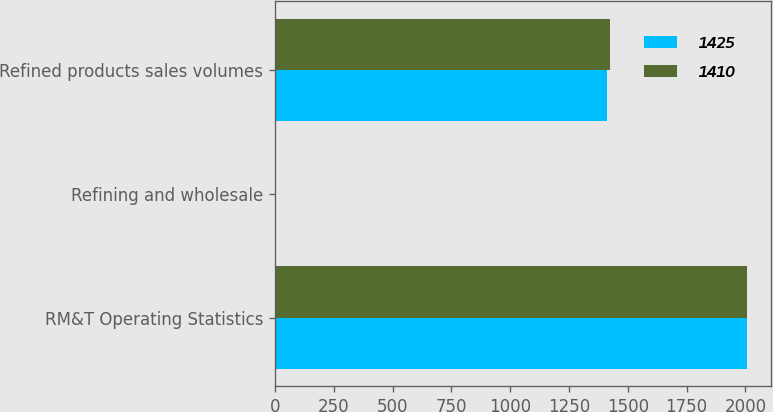Convert chart to OTSL. <chart><loc_0><loc_0><loc_500><loc_500><stacked_bar_chart><ecel><fcel>RM&T Operating Statistics<fcel>Refining and wholesale<fcel>Refined products sales volumes<nl><fcel>1425<fcel>2007<fcel>0.18<fcel>1410<nl><fcel>1410<fcel>2006<fcel>0.23<fcel>1425<nl></chart> 